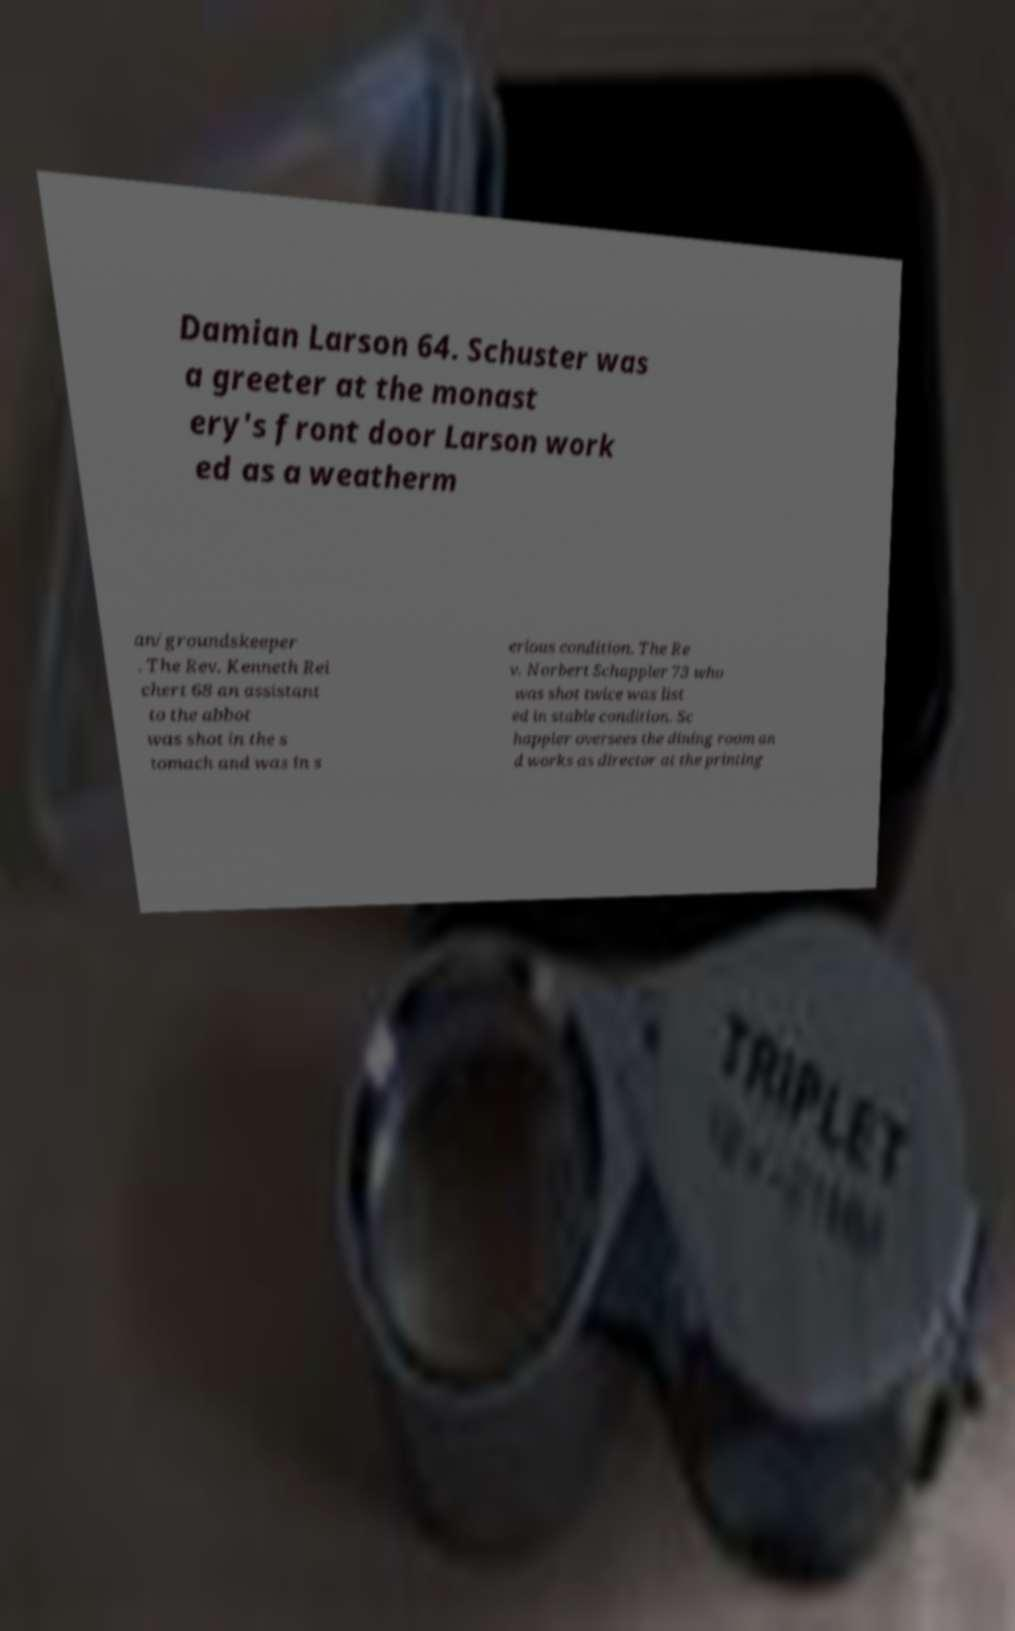What messages or text are displayed in this image? I need them in a readable, typed format. Damian Larson 64. Schuster was a greeter at the monast ery's front door Larson work ed as a weatherm an/groundskeeper . The Rev. Kenneth Rei chert 68 an assistant to the abbot was shot in the s tomach and was in s erious condition. The Re v. Norbert Schappler 73 who was shot twice was list ed in stable condition. Sc happler oversees the dining room an d works as director at the printing 